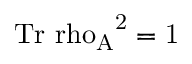Convert formula to latex. <formula><loc_0><loc_0><loc_500><loc_500>{ T r } { \ r h o _ { A } } ^ { 2 } = 1</formula> 